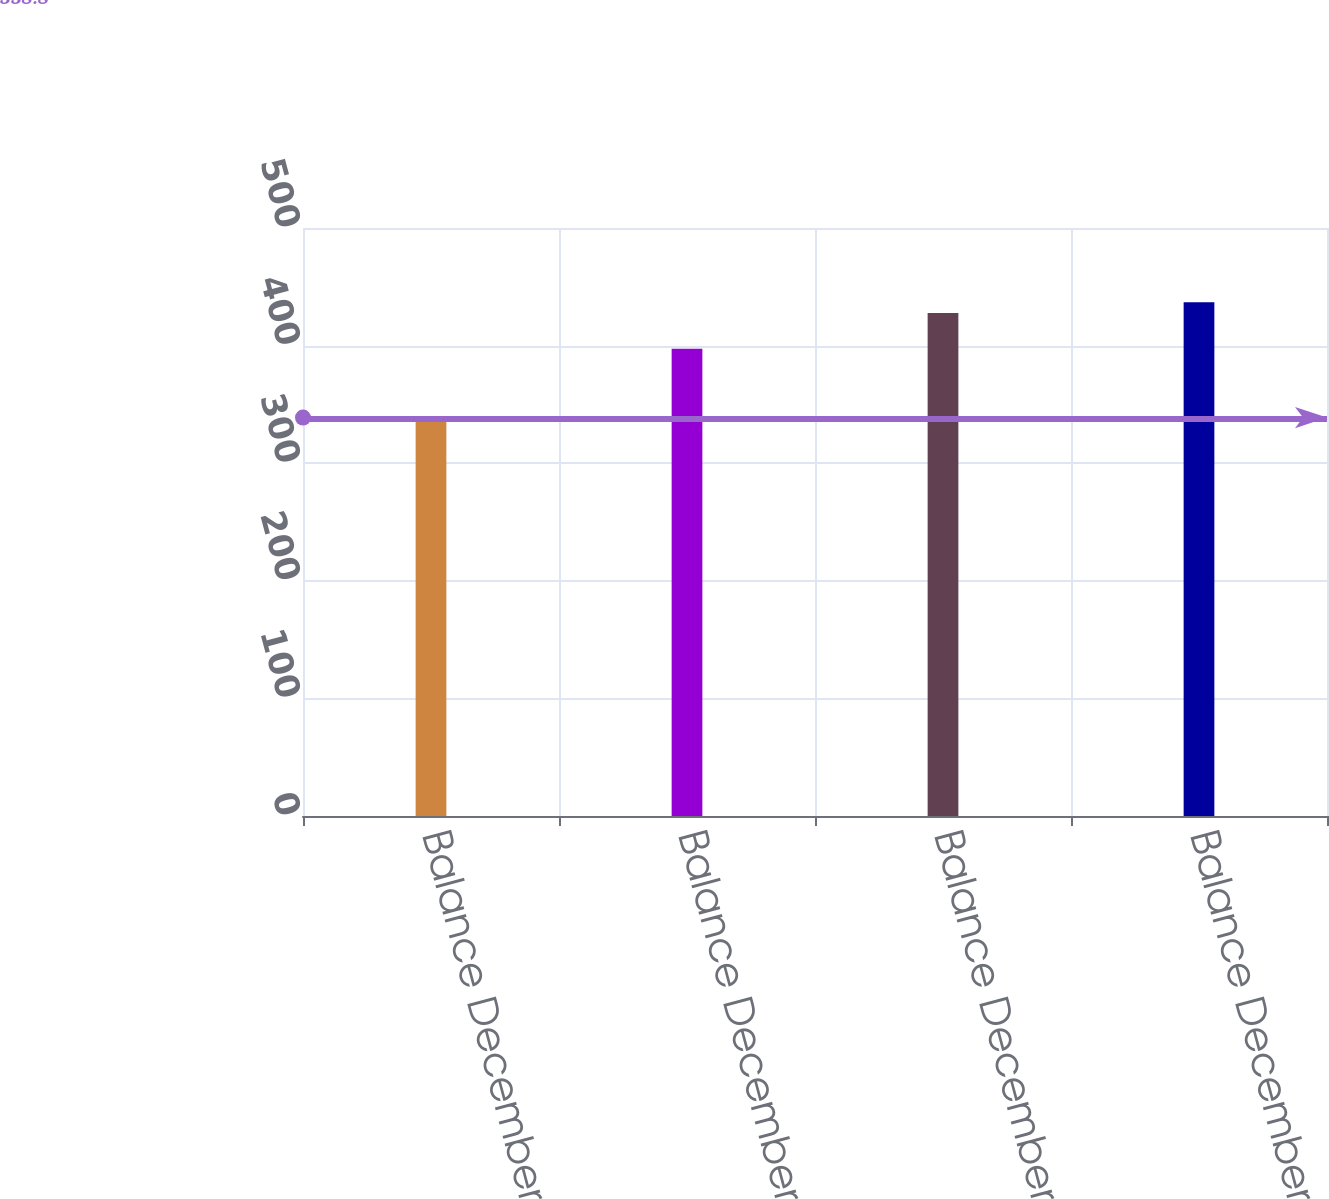Convert chart to OTSL. <chart><loc_0><loc_0><loc_500><loc_500><bar_chart><fcel>Balance December 31 2003<fcel>Balance December 31 2004<fcel>Balance December 31 2005<fcel>Balance December 31 2006<nl><fcel>338.8<fcel>397.4<fcel>427.7<fcel>436.92<nl></chart> 